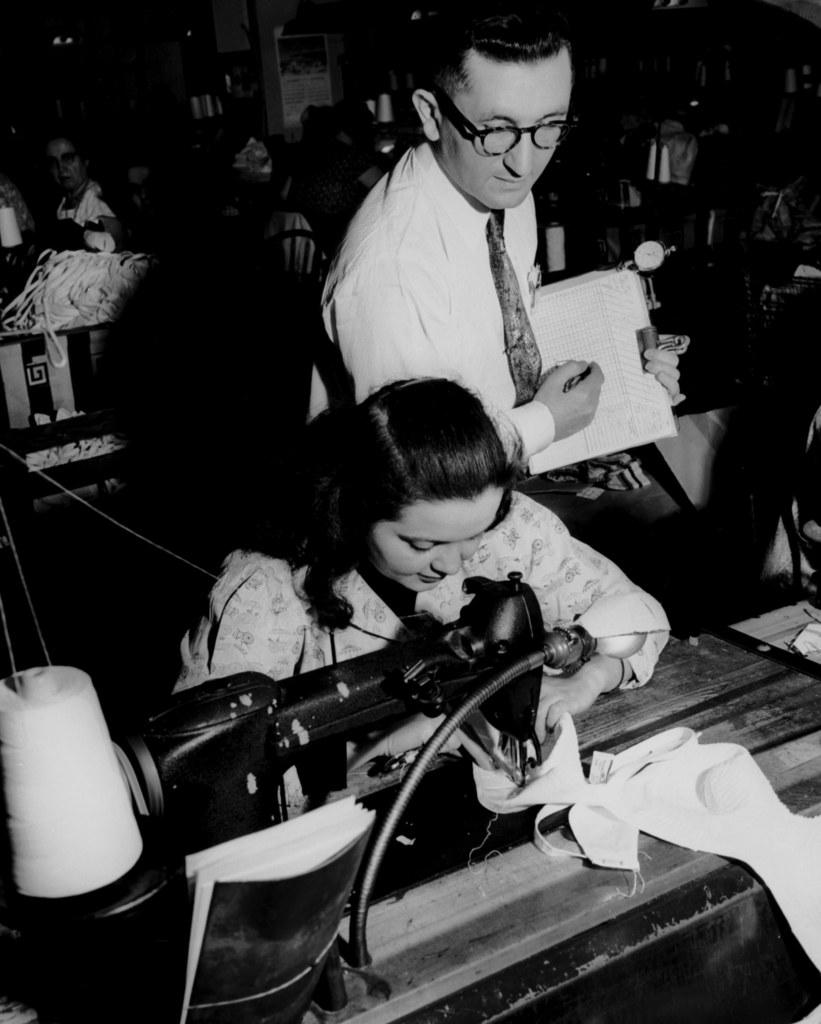How many people are present in the image? There are two persons in the image. What object can be seen in the image besides the people? There is a sewing machine in the image. Can you describe the background of the image? There are additional persons visible in the background of the image. What is the color scheme of the image? The image is in black and white color. Can you see any ocean waves in the image? There is no ocean or waves present in the image; it features two persons and a sewing machine in a black and white setting. 